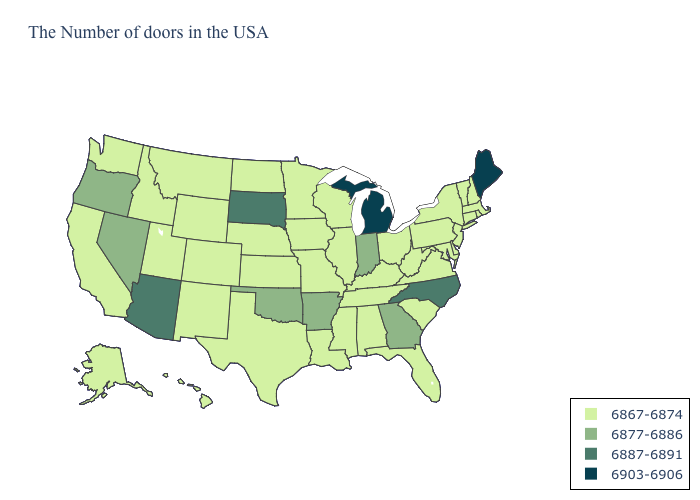Does Idaho have the same value as Indiana?
Be succinct. No. Among the states that border Washington , which have the lowest value?
Be succinct. Idaho. How many symbols are there in the legend?
Quick response, please. 4. Does Georgia have a higher value than Oklahoma?
Keep it brief. No. Does Indiana have the lowest value in the MidWest?
Short answer required. No. Among the states that border Michigan , does Wisconsin have the highest value?
Be succinct. No. What is the lowest value in the USA?
Write a very short answer. 6867-6874. Name the states that have a value in the range 6887-6891?
Short answer required. North Carolina, South Dakota, Arizona. Name the states that have a value in the range 6887-6891?
Be succinct. North Carolina, South Dakota, Arizona. What is the value of West Virginia?
Quick response, please. 6867-6874. Among the states that border Idaho , which have the lowest value?
Give a very brief answer. Wyoming, Utah, Montana, Washington. Does Oklahoma have the lowest value in the USA?
Keep it brief. No. Is the legend a continuous bar?
Keep it brief. No. Among the states that border California , does Oregon have the lowest value?
Answer briefly. Yes. Name the states that have a value in the range 6877-6886?
Keep it brief. Georgia, Indiana, Arkansas, Oklahoma, Nevada, Oregon. 